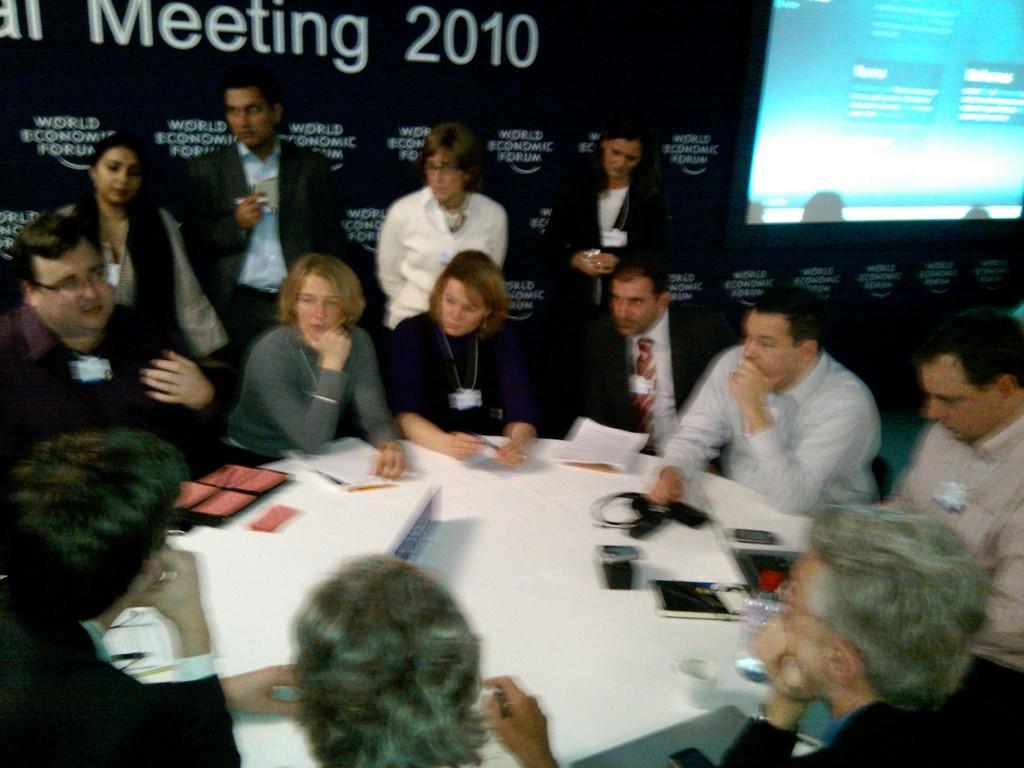Could you give a brief overview of what you see in this image? In this image there is a group of people sitting in chairs, in front of them on the table there are some objects, behind them there are a few people standing, behind them there is a screen and a banner. 